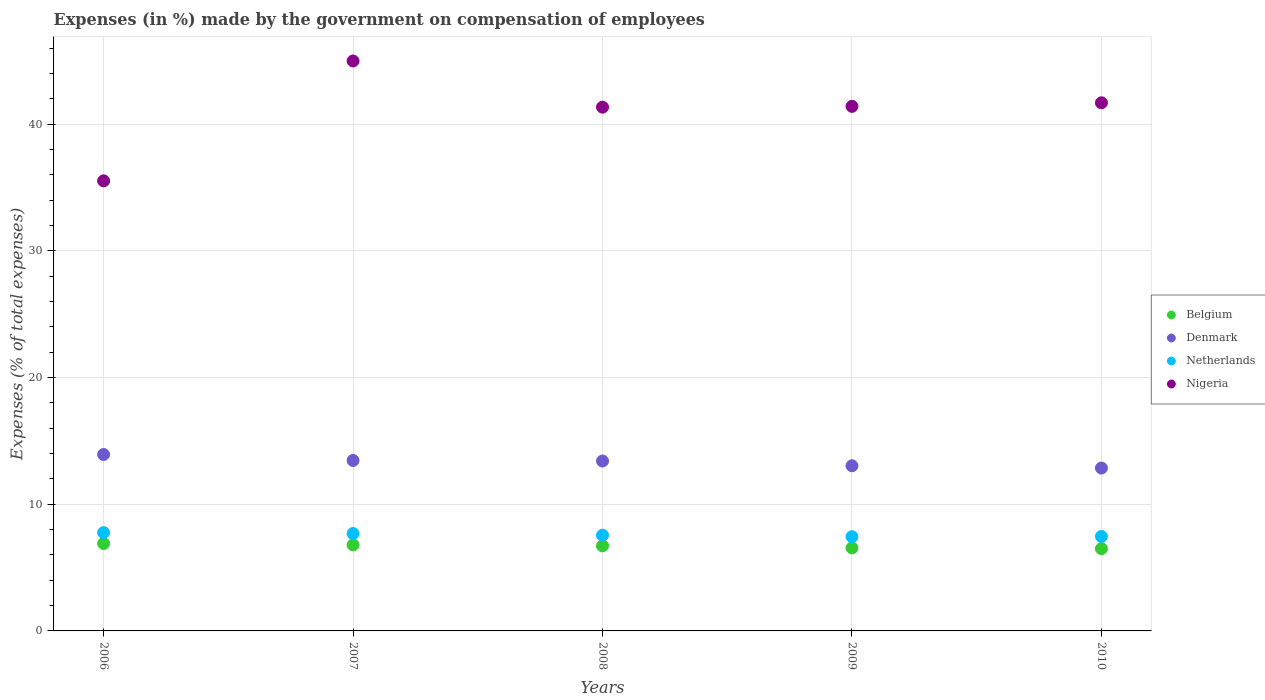What is the percentage of expenses made by the government on compensation of employees in Belgium in 2008?
Make the answer very short. 6.71. Across all years, what is the maximum percentage of expenses made by the government on compensation of employees in Netherlands?
Offer a terse response. 7.76. Across all years, what is the minimum percentage of expenses made by the government on compensation of employees in Nigeria?
Keep it short and to the point. 35.53. In which year was the percentage of expenses made by the government on compensation of employees in Netherlands minimum?
Your answer should be very brief. 2009. What is the total percentage of expenses made by the government on compensation of employees in Denmark in the graph?
Provide a short and direct response. 66.7. What is the difference between the percentage of expenses made by the government on compensation of employees in Denmark in 2007 and that in 2010?
Provide a succinct answer. 0.6. What is the difference between the percentage of expenses made by the government on compensation of employees in Denmark in 2010 and the percentage of expenses made by the government on compensation of employees in Nigeria in 2007?
Offer a very short reply. -32.14. What is the average percentage of expenses made by the government on compensation of employees in Netherlands per year?
Offer a terse response. 7.58. In the year 2010, what is the difference between the percentage of expenses made by the government on compensation of employees in Netherlands and percentage of expenses made by the government on compensation of employees in Belgium?
Provide a succinct answer. 0.97. What is the ratio of the percentage of expenses made by the government on compensation of employees in Belgium in 2006 to that in 2007?
Give a very brief answer. 1.02. Is the percentage of expenses made by the government on compensation of employees in Belgium in 2006 less than that in 2010?
Ensure brevity in your answer.  No. What is the difference between the highest and the second highest percentage of expenses made by the government on compensation of employees in Netherlands?
Ensure brevity in your answer.  0.07. What is the difference between the highest and the lowest percentage of expenses made by the government on compensation of employees in Nigeria?
Ensure brevity in your answer.  9.46. In how many years, is the percentage of expenses made by the government on compensation of employees in Denmark greater than the average percentage of expenses made by the government on compensation of employees in Denmark taken over all years?
Offer a very short reply. 3. Is the sum of the percentage of expenses made by the government on compensation of employees in Nigeria in 2006 and 2009 greater than the maximum percentage of expenses made by the government on compensation of employees in Denmark across all years?
Make the answer very short. Yes. Is it the case that in every year, the sum of the percentage of expenses made by the government on compensation of employees in Nigeria and percentage of expenses made by the government on compensation of employees in Denmark  is greater than the percentage of expenses made by the government on compensation of employees in Netherlands?
Your response must be concise. Yes. Is the percentage of expenses made by the government on compensation of employees in Belgium strictly greater than the percentage of expenses made by the government on compensation of employees in Netherlands over the years?
Offer a terse response. No. How many dotlines are there?
Your answer should be compact. 4. How many years are there in the graph?
Ensure brevity in your answer.  5. Does the graph contain any zero values?
Offer a very short reply. No. How many legend labels are there?
Your answer should be very brief. 4. How are the legend labels stacked?
Offer a terse response. Vertical. What is the title of the graph?
Give a very brief answer. Expenses (in %) made by the government on compensation of employees. What is the label or title of the X-axis?
Give a very brief answer. Years. What is the label or title of the Y-axis?
Give a very brief answer. Expenses (% of total expenses). What is the Expenses (% of total expenses) in Belgium in 2006?
Give a very brief answer. 6.9. What is the Expenses (% of total expenses) in Denmark in 2006?
Offer a terse response. 13.93. What is the Expenses (% of total expenses) in Netherlands in 2006?
Ensure brevity in your answer.  7.76. What is the Expenses (% of total expenses) of Nigeria in 2006?
Provide a succinct answer. 35.53. What is the Expenses (% of total expenses) in Belgium in 2007?
Your answer should be compact. 6.79. What is the Expenses (% of total expenses) of Denmark in 2007?
Give a very brief answer. 13.46. What is the Expenses (% of total expenses) of Netherlands in 2007?
Offer a very short reply. 7.69. What is the Expenses (% of total expenses) in Nigeria in 2007?
Ensure brevity in your answer.  45. What is the Expenses (% of total expenses) of Belgium in 2008?
Provide a short and direct response. 6.71. What is the Expenses (% of total expenses) in Denmark in 2008?
Your answer should be very brief. 13.41. What is the Expenses (% of total expenses) of Netherlands in 2008?
Your answer should be compact. 7.56. What is the Expenses (% of total expenses) in Nigeria in 2008?
Your answer should be very brief. 41.35. What is the Expenses (% of total expenses) in Belgium in 2009?
Give a very brief answer. 6.56. What is the Expenses (% of total expenses) of Denmark in 2009?
Your answer should be compact. 13.04. What is the Expenses (% of total expenses) of Netherlands in 2009?
Provide a succinct answer. 7.44. What is the Expenses (% of total expenses) of Nigeria in 2009?
Offer a very short reply. 41.42. What is the Expenses (% of total expenses) in Belgium in 2010?
Your answer should be very brief. 6.49. What is the Expenses (% of total expenses) of Denmark in 2010?
Provide a succinct answer. 12.86. What is the Expenses (% of total expenses) of Netherlands in 2010?
Provide a short and direct response. 7.46. What is the Expenses (% of total expenses) in Nigeria in 2010?
Offer a terse response. 41.7. Across all years, what is the maximum Expenses (% of total expenses) of Belgium?
Keep it short and to the point. 6.9. Across all years, what is the maximum Expenses (% of total expenses) in Denmark?
Offer a very short reply. 13.93. Across all years, what is the maximum Expenses (% of total expenses) of Netherlands?
Provide a succinct answer. 7.76. Across all years, what is the maximum Expenses (% of total expenses) in Nigeria?
Provide a short and direct response. 45. Across all years, what is the minimum Expenses (% of total expenses) in Belgium?
Give a very brief answer. 6.49. Across all years, what is the minimum Expenses (% of total expenses) in Denmark?
Provide a succinct answer. 12.86. Across all years, what is the minimum Expenses (% of total expenses) of Netherlands?
Your answer should be very brief. 7.44. Across all years, what is the minimum Expenses (% of total expenses) in Nigeria?
Keep it short and to the point. 35.53. What is the total Expenses (% of total expenses) of Belgium in the graph?
Offer a very short reply. 33.45. What is the total Expenses (% of total expenses) in Denmark in the graph?
Make the answer very short. 66.7. What is the total Expenses (% of total expenses) of Netherlands in the graph?
Give a very brief answer. 37.91. What is the total Expenses (% of total expenses) in Nigeria in the graph?
Ensure brevity in your answer.  205. What is the difference between the Expenses (% of total expenses) in Belgium in 2006 and that in 2007?
Your response must be concise. 0.1. What is the difference between the Expenses (% of total expenses) of Denmark in 2006 and that in 2007?
Give a very brief answer. 0.47. What is the difference between the Expenses (% of total expenses) of Netherlands in 2006 and that in 2007?
Offer a very short reply. 0.07. What is the difference between the Expenses (% of total expenses) in Nigeria in 2006 and that in 2007?
Your response must be concise. -9.46. What is the difference between the Expenses (% of total expenses) of Belgium in 2006 and that in 2008?
Your answer should be compact. 0.19. What is the difference between the Expenses (% of total expenses) of Denmark in 2006 and that in 2008?
Provide a succinct answer. 0.52. What is the difference between the Expenses (% of total expenses) in Netherlands in 2006 and that in 2008?
Offer a terse response. 0.2. What is the difference between the Expenses (% of total expenses) in Nigeria in 2006 and that in 2008?
Your response must be concise. -5.82. What is the difference between the Expenses (% of total expenses) of Belgium in 2006 and that in 2009?
Make the answer very short. 0.34. What is the difference between the Expenses (% of total expenses) of Denmark in 2006 and that in 2009?
Make the answer very short. 0.89. What is the difference between the Expenses (% of total expenses) in Netherlands in 2006 and that in 2009?
Your answer should be compact. 0.32. What is the difference between the Expenses (% of total expenses) of Nigeria in 2006 and that in 2009?
Your answer should be compact. -5.88. What is the difference between the Expenses (% of total expenses) in Belgium in 2006 and that in 2010?
Your response must be concise. 0.41. What is the difference between the Expenses (% of total expenses) of Denmark in 2006 and that in 2010?
Ensure brevity in your answer.  1.07. What is the difference between the Expenses (% of total expenses) of Netherlands in 2006 and that in 2010?
Keep it short and to the point. 0.3. What is the difference between the Expenses (% of total expenses) in Nigeria in 2006 and that in 2010?
Keep it short and to the point. -6.16. What is the difference between the Expenses (% of total expenses) of Belgium in 2007 and that in 2008?
Your answer should be very brief. 0.08. What is the difference between the Expenses (% of total expenses) in Denmark in 2007 and that in 2008?
Make the answer very short. 0.04. What is the difference between the Expenses (% of total expenses) in Netherlands in 2007 and that in 2008?
Provide a succinct answer. 0.13. What is the difference between the Expenses (% of total expenses) of Nigeria in 2007 and that in 2008?
Ensure brevity in your answer.  3.65. What is the difference between the Expenses (% of total expenses) in Belgium in 2007 and that in 2009?
Provide a short and direct response. 0.24. What is the difference between the Expenses (% of total expenses) of Denmark in 2007 and that in 2009?
Provide a short and direct response. 0.42. What is the difference between the Expenses (% of total expenses) of Netherlands in 2007 and that in 2009?
Your answer should be very brief. 0.25. What is the difference between the Expenses (% of total expenses) of Nigeria in 2007 and that in 2009?
Provide a short and direct response. 3.58. What is the difference between the Expenses (% of total expenses) of Belgium in 2007 and that in 2010?
Make the answer very short. 0.3. What is the difference between the Expenses (% of total expenses) in Denmark in 2007 and that in 2010?
Keep it short and to the point. 0.6. What is the difference between the Expenses (% of total expenses) of Netherlands in 2007 and that in 2010?
Your answer should be very brief. 0.23. What is the difference between the Expenses (% of total expenses) of Nigeria in 2007 and that in 2010?
Your response must be concise. 3.3. What is the difference between the Expenses (% of total expenses) of Belgium in 2008 and that in 2009?
Provide a short and direct response. 0.16. What is the difference between the Expenses (% of total expenses) in Denmark in 2008 and that in 2009?
Give a very brief answer. 0.38. What is the difference between the Expenses (% of total expenses) of Netherlands in 2008 and that in 2009?
Offer a terse response. 0.12. What is the difference between the Expenses (% of total expenses) of Nigeria in 2008 and that in 2009?
Your answer should be very brief. -0.06. What is the difference between the Expenses (% of total expenses) of Belgium in 2008 and that in 2010?
Make the answer very short. 0.22. What is the difference between the Expenses (% of total expenses) of Denmark in 2008 and that in 2010?
Give a very brief answer. 0.55. What is the difference between the Expenses (% of total expenses) in Netherlands in 2008 and that in 2010?
Provide a short and direct response. 0.1. What is the difference between the Expenses (% of total expenses) in Nigeria in 2008 and that in 2010?
Provide a succinct answer. -0.35. What is the difference between the Expenses (% of total expenses) of Belgium in 2009 and that in 2010?
Give a very brief answer. 0.06. What is the difference between the Expenses (% of total expenses) in Denmark in 2009 and that in 2010?
Give a very brief answer. 0.18. What is the difference between the Expenses (% of total expenses) in Netherlands in 2009 and that in 2010?
Make the answer very short. -0.02. What is the difference between the Expenses (% of total expenses) of Nigeria in 2009 and that in 2010?
Provide a short and direct response. -0.28. What is the difference between the Expenses (% of total expenses) of Belgium in 2006 and the Expenses (% of total expenses) of Denmark in 2007?
Provide a short and direct response. -6.56. What is the difference between the Expenses (% of total expenses) of Belgium in 2006 and the Expenses (% of total expenses) of Netherlands in 2007?
Offer a very short reply. -0.79. What is the difference between the Expenses (% of total expenses) of Belgium in 2006 and the Expenses (% of total expenses) of Nigeria in 2007?
Offer a very short reply. -38.1. What is the difference between the Expenses (% of total expenses) of Denmark in 2006 and the Expenses (% of total expenses) of Netherlands in 2007?
Make the answer very short. 6.24. What is the difference between the Expenses (% of total expenses) in Denmark in 2006 and the Expenses (% of total expenses) in Nigeria in 2007?
Provide a short and direct response. -31.07. What is the difference between the Expenses (% of total expenses) in Netherlands in 2006 and the Expenses (% of total expenses) in Nigeria in 2007?
Ensure brevity in your answer.  -37.24. What is the difference between the Expenses (% of total expenses) of Belgium in 2006 and the Expenses (% of total expenses) of Denmark in 2008?
Your answer should be compact. -6.52. What is the difference between the Expenses (% of total expenses) of Belgium in 2006 and the Expenses (% of total expenses) of Netherlands in 2008?
Your answer should be very brief. -0.66. What is the difference between the Expenses (% of total expenses) of Belgium in 2006 and the Expenses (% of total expenses) of Nigeria in 2008?
Your answer should be very brief. -34.45. What is the difference between the Expenses (% of total expenses) in Denmark in 2006 and the Expenses (% of total expenses) in Netherlands in 2008?
Offer a terse response. 6.37. What is the difference between the Expenses (% of total expenses) of Denmark in 2006 and the Expenses (% of total expenses) of Nigeria in 2008?
Provide a short and direct response. -27.42. What is the difference between the Expenses (% of total expenses) in Netherlands in 2006 and the Expenses (% of total expenses) in Nigeria in 2008?
Provide a succinct answer. -33.59. What is the difference between the Expenses (% of total expenses) of Belgium in 2006 and the Expenses (% of total expenses) of Denmark in 2009?
Keep it short and to the point. -6.14. What is the difference between the Expenses (% of total expenses) of Belgium in 2006 and the Expenses (% of total expenses) of Netherlands in 2009?
Offer a terse response. -0.54. What is the difference between the Expenses (% of total expenses) in Belgium in 2006 and the Expenses (% of total expenses) in Nigeria in 2009?
Provide a succinct answer. -34.52. What is the difference between the Expenses (% of total expenses) in Denmark in 2006 and the Expenses (% of total expenses) in Netherlands in 2009?
Your answer should be very brief. 6.49. What is the difference between the Expenses (% of total expenses) of Denmark in 2006 and the Expenses (% of total expenses) of Nigeria in 2009?
Keep it short and to the point. -27.49. What is the difference between the Expenses (% of total expenses) of Netherlands in 2006 and the Expenses (% of total expenses) of Nigeria in 2009?
Ensure brevity in your answer.  -33.65. What is the difference between the Expenses (% of total expenses) in Belgium in 2006 and the Expenses (% of total expenses) in Denmark in 2010?
Your answer should be very brief. -5.96. What is the difference between the Expenses (% of total expenses) in Belgium in 2006 and the Expenses (% of total expenses) in Netherlands in 2010?
Offer a very short reply. -0.56. What is the difference between the Expenses (% of total expenses) in Belgium in 2006 and the Expenses (% of total expenses) in Nigeria in 2010?
Make the answer very short. -34.8. What is the difference between the Expenses (% of total expenses) of Denmark in 2006 and the Expenses (% of total expenses) of Netherlands in 2010?
Your answer should be very brief. 6.47. What is the difference between the Expenses (% of total expenses) of Denmark in 2006 and the Expenses (% of total expenses) of Nigeria in 2010?
Give a very brief answer. -27.77. What is the difference between the Expenses (% of total expenses) of Netherlands in 2006 and the Expenses (% of total expenses) of Nigeria in 2010?
Provide a short and direct response. -33.94. What is the difference between the Expenses (% of total expenses) in Belgium in 2007 and the Expenses (% of total expenses) in Denmark in 2008?
Keep it short and to the point. -6.62. What is the difference between the Expenses (% of total expenses) in Belgium in 2007 and the Expenses (% of total expenses) in Netherlands in 2008?
Provide a short and direct response. -0.76. What is the difference between the Expenses (% of total expenses) of Belgium in 2007 and the Expenses (% of total expenses) of Nigeria in 2008?
Offer a very short reply. -34.56. What is the difference between the Expenses (% of total expenses) in Denmark in 2007 and the Expenses (% of total expenses) in Netherlands in 2008?
Keep it short and to the point. 5.9. What is the difference between the Expenses (% of total expenses) of Denmark in 2007 and the Expenses (% of total expenses) of Nigeria in 2008?
Offer a terse response. -27.89. What is the difference between the Expenses (% of total expenses) in Netherlands in 2007 and the Expenses (% of total expenses) in Nigeria in 2008?
Offer a very short reply. -33.66. What is the difference between the Expenses (% of total expenses) of Belgium in 2007 and the Expenses (% of total expenses) of Denmark in 2009?
Keep it short and to the point. -6.24. What is the difference between the Expenses (% of total expenses) in Belgium in 2007 and the Expenses (% of total expenses) in Netherlands in 2009?
Your response must be concise. -0.64. What is the difference between the Expenses (% of total expenses) of Belgium in 2007 and the Expenses (% of total expenses) of Nigeria in 2009?
Your answer should be compact. -34.62. What is the difference between the Expenses (% of total expenses) in Denmark in 2007 and the Expenses (% of total expenses) in Netherlands in 2009?
Make the answer very short. 6.02. What is the difference between the Expenses (% of total expenses) of Denmark in 2007 and the Expenses (% of total expenses) of Nigeria in 2009?
Make the answer very short. -27.96. What is the difference between the Expenses (% of total expenses) of Netherlands in 2007 and the Expenses (% of total expenses) of Nigeria in 2009?
Provide a short and direct response. -33.73. What is the difference between the Expenses (% of total expenses) of Belgium in 2007 and the Expenses (% of total expenses) of Denmark in 2010?
Give a very brief answer. -6.07. What is the difference between the Expenses (% of total expenses) of Belgium in 2007 and the Expenses (% of total expenses) of Netherlands in 2010?
Your answer should be very brief. -0.67. What is the difference between the Expenses (% of total expenses) of Belgium in 2007 and the Expenses (% of total expenses) of Nigeria in 2010?
Offer a terse response. -34.9. What is the difference between the Expenses (% of total expenses) in Denmark in 2007 and the Expenses (% of total expenses) in Netherlands in 2010?
Give a very brief answer. 6. What is the difference between the Expenses (% of total expenses) in Denmark in 2007 and the Expenses (% of total expenses) in Nigeria in 2010?
Make the answer very short. -28.24. What is the difference between the Expenses (% of total expenses) in Netherlands in 2007 and the Expenses (% of total expenses) in Nigeria in 2010?
Ensure brevity in your answer.  -34.01. What is the difference between the Expenses (% of total expenses) of Belgium in 2008 and the Expenses (% of total expenses) of Denmark in 2009?
Keep it short and to the point. -6.33. What is the difference between the Expenses (% of total expenses) of Belgium in 2008 and the Expenses (% of total expenses) of Netherlands in 2009?
Offer a very short reply. -0.72. What is the difference between the Expenses (% of total expenses) of Belgium in 2008 and the Expenses (% of total expenses) of Nigeria in 2009?
Offer a very short reply. -34.7. What is the difference between the Expenses (% of total expenses) of Denmark in 2008 and the Expenses (% of total expenses) of Netherlands in 2009?
Make the answer very short. 5.98. What is the difference between the Expenses (% of total expenses) in Denmark in 2008 and the Expenses (% of total expenses) in Nigeria in 2009?
Provide a short and direct response. -28. What is the difference between the Expenses (% of total expenses) in Netherlands in 2008 and the Expenses (% of total expenses) in Nigeria in 2009?
Give a very brief answer. -33.86. What is the difference between the Expenses (% of total expenses) in Belgium in 2008 and the Expenses (% of total expenses) in Denmark in 2010?
Keep it short and to the point. -6.15. What is the difference between the Expenses (% of total expenses) in Belgium in 2008 and the Expenses (% of total expenses) in Netherlands in 2010?
Make the answer very short. -0.75. What is the difference between the Expenses (% of total expenses) of Belgium in 2008 and the Expenses (% of total expenses) of Nigeria in 2010?
Your answer should be compact. -34.98. What is the difference between the Expenses (% of total expenses) in Denmark in 2008 and the Expenses (% of total expenses) in Netherlands in 2010?
Provide a succinct answer. 5.95. What is the difference between the Expenses (% of total expenses) of Denmark in 2008 and the Expenses (% of total expenses) of Nigeria in 2010?
Provide a short and direct response. -28.28. What is the difference between the Expenses (% of total expenses) in Netherlands in 2008 and the Expenses (% of total expenses) in Nigeria in 2010?
Keep it short and to the point. -34.14. What is the difference between the Expenses (% of total expenses) of Belgium in 2009 and the Expenses (% of total expenses) of Denmark in 2010?
Provide a succinct answer. -6.3. What is the difference between the Expenses (% of total expenses) in Belgium in 2009 and the Expenses (% of total expenses) in Netherlands in 2010?
Ensure brevity in your answer.  -0.91. What is the difference between the Expenses (% of total expenses) of Belgium in 2009 and the Expenses (% of total expenses) of Nigeria in 2010?
Make the answer very short. -35.14. What is the difference between the Expenses (% of total expenses) of Denmark in 2009 and the Expenses (% of total expenses) of Netherlands in 2010?
Give a very brief answer. 5.58. What is the difference between the Expenses (% of total expenses) in Denmark in 2009 and the Expenses (% of total expenses) in Nigeria in 2010?
Give a very brief answer. -28.66. What is the difference between the Expenses (% of total expenses) in Netherlands in 2009 and the Expenses (% of total expenses) in Nigeria in 2010?
Offer a terse response. -34.26. What is the average Expenses (% of total expenses) in Belgium per year?
Provide a short and direct response. 6.69. What is the average Expenses (% of total expenses) of Denmark per year?
Your response must be concise. 13.34. What is the average Expenses (% of total expenses) in Netherlands per year?
Ensure brevity in your answer.  7.58. What is the average Expenses (% of total expenses) in Nigeria per year?
Your answer should be compact. 41. In the year 2006, what is the difference between the Expenses (% of total expenses) in Belgium and Expenses (% of total expenses) in Denmark?
Provide a short and direct response. -7.03. In the year 2006, what is the difference between the Expenses (% of total expenses) of Belgium and Expenses (% of total expenses) of Netherlands?
Your response must be concise. -0.86. In the year 2006, what is the difference between the Expenses (% of total expenses) of Belgium and Expenses (% of total expenses) of Nigeria?
Offer a terse response. -28.64. In the year 2006, what is the difference between the Expenses (% of total expenses) in Denmark and Expenses (% of total expenses) in Netherlands?
Make the answer very short. 6.17. In the year 2006, what is the difference between the Expenses (% of total expenses) of Denmark and Expenses (% of total expenses) of Nigeria?
Offer a very short reply. -21.61. In the year 2006, what is the difference between the Expenses (% of total expenses) of Netherlands and Expenses (% of total expenses) of Nigeria?
Provide a succinct answer. -27.77. In the year 2007, what is the difference between the Expenses (% of total expenses) in Belgium and Expenses (% of total expenses) in Denmark?
Offer a terse response. -6.66. In the year 2007, what is the difference between the Expenses (% of total expenses) of Belgium and Expenses (% of total expenses) of Netherlands?
Keep it short and to the point. -0.9. In the year 2007, what is the difference between the Expenses (% of total expenses) in Belgium and Expenses (% of total expenses) in Nigeria?
Give a very brief answer. -38.21. In the year 2007, what is the difference between the Expenses (% of total expenses) in Denmark and Expenses (% of total expenses) in Netherlands?
Offer a terse response. 5.77. In the year 2007, what is the difference between the Expenses (% of total expenses) of Denmark and Expenses (% of total expenses) of Nigeria?
Your response must be concise. -31.54. In the year 2007, what is the difference between the Expenses (% of total expenses) of Netherlands and Expenses (% of total expenses) of Nigeria?
Your answer should be compact. -37.31. In the year 2008, what is the difference between the Expenses (% of total expenses) of Belgium and Expenses (% of total expenses) of Denmark?
Provide a succinct answer. -6.7. In the year 2008, what is the difference between the Expenses (% of total expenses) in Belgium and Expenses (% of total expenses) in Netherlands?
Make the answer very short. -0.84. In the year 2008, what is the difference between the Expenses (% of total expenses) of Belgium and Expenses (% of total expenses) of Nigeria?
Give a very brief answer. -34.64. In the year 2008, what is the difference between the Expenses (% of total expenses) in Denmark and Expenses (% of total expenses) in Netherlands?
Keep it short and to the point. 5.86. In the year 2008, what is the difference between the Expenses (% of total expenses) in Denmark and Expenses (% of total expenses) in Nigeria?
Your response must be concise. -27.94. In the year 2008, what is the difference between the Expenses (% of total expenses) of Netherlands and Expenses (% of total expenses) of Nigeria?
Keep it short and to the point. -33.79. In the year 2009, what is the difference between the Expenses (% of total expenses) of Belgium and Expenses (% of total expenses) of Denmark?
Give a very brief answer. -6.48. In the year 2009, what is the difference between the Expenses (% of total expenses) in Belgium and Expenses (% of total expenses) in Netherlands?
Offer a terse response. -0.88. In the year 2009, what is the difference between the Expenses (% of total expenses) of Belgium and Expenses (% of total expenses) of Nigeria?
Make the answer very short. -34.86. In the year 2009, what is the difference between the Expenses (% of total expenses) in Denmark and Expenses (% of total expenses) in Netherlands?
Make the answer very short. 5.6. In the year 2009, what is the difference between the Expenses (% of total expenses) in Denmark and Expenses (% of total expenses) in Nigeria?
Your answer should be compact. -28.38. In the year 2009, what is the difference between the Expenses (% of total expenses) in Netherlands and Expenses (% of total expenses) in Nigeria?
Give a very brief answer. -33.98. In the year 2010, what is the difference between the Expenses (% of total expenses) of Belgium and Expenses (% of total expenses) of Denmark?
Provide a succinct answer. -6.37. In the year 2010, what is the difference between the Expenses (% of total expenses) in Belgium and Expenses (% of total expenses) in Netherlands?
Your response must be concise. -0.97. In the year 2010, what is the difference between the Expenses (% of total expenses) in Belgium and Expenses (% of total expenses) in Nigeria?
Give a very brief answer. -35.2. In the year 2010, what is the difference between the Expenses (% of total expenses) in Denmark and Expenses (% of total expenses) in Netherlands?
Ensure brevity in your answer.  5.4. In the year 2010, what is the difference between the Expenses (% of total expenses) of Denmark and Expenses (% of total expenses) of Nigeria?
Offer a very short reply. -28.84. In the year 2010, what is the difference between the Expenses (% of total expenses) in Netherlands and Expenses (% of total expenses) in Nigeria?
Offer a very short reply. -34.23. What is the ratio of the Expenses (% of total expenses) in Belgium in 2006 to that in 2007?
Offer a terse response. 1.02. What is the ratio of the Expenses (% of total expenses) of Denmark in 2006 to that in 2007?
Offer a very short reply. 1.03. What is the ratio of the Expenses (% of total expenses) of Netherlands in 2006 to that in 2007?
Provide a succinct answer. 1.01. What is the ratio of the Expenses (% of total expenses) in Nigeria in 2006 to that in 2007?
Offer a very short reply. 0.79. What is the ratio of the Expenses (% of total expenses) in Belgium in 2006 to that in 2008?
Your answer should be compact. 1.03. What is the ratio of the Expenses (% of total expenses) in Denmark in 2006 to that in 2008?
Your answer should be very brief. 1.04. What is the ratio of the Expenses (% of total expenses) in Nigeria in 2006 to that in 2008?
Offer a very short reply. 0.86. What is the ratio of the Expenses (% of total expenses) of Belgium in 2006 to that in 2009?
Offer a terse response. 1.05. What is the ratio of the Expenses (% of total expenses) in Denmark in 2006 to that in 2009?
Give a very brief answer. 1.07. What is the ratio of the Expenses (% of total expenses) in Netherlands in 2006 to that in 2009?
Keep it short and to the point. 1.04. What is the ratio of the Expenses (% of total expenses) in Nigeria in 2006 to that in 2009?
Your response must be concise. 0.86. What is the ratio of the Expenses (% of total expenses) of Denmark in 2006 to that in 2010?
Make the answer very short. 1.08. What is the ratio of the Expenses (% of total expenses) of Netherlands in 2006 to that in 2010?
Your response must be concise. 1.04. What is the ratio of the Expenses (% of total expenses) of Nigeria in 2006 to that in 2010?
Offer a very short reply. 0.85. What is the ratio of the Expenses (% of total expenses) of Belgium in 2007 to that in 2008?
Ensure brevity in your answer.  1.01. What is the ratio of the Expenses (% of total expenses) in Denmark in 2007 to that in 2008?
Offer a terse response. 1. What is the ratio of the Expenses (% of total expenses) of Netherlands in 2007 to that in 2008?
Ensure brevity in your answer.  1.02. What is the ratio of the Expenses (% of total expenses) of Nigeria in 2007 to that in 2008?
Offer a terse response. 1.09. What is the ratio of the Expenses (% of total expenses) of Belgium in 2007 to that in 2009?
Provide a succinct answer. 1.04. What is the ratio of the Expenses (% of total expenses) in Denmark in 2007 to that in 2009?
Give a very brief answer. 1.03. What is the ratio of the Expenses (% of total expenses) in Netherlands in 2007 to that in 2009?
Ensure brevity in your answer.  1.03. What is the ratio of the Expenses (% of total expenses) of Nigeria in 2007 to that in 2009?
Your answer should be compact. 1.09. What is the ratio of the Expenses (% of total expenses) in Belgium in 2007 to that in 2010?
Your answer should be very brief. 1.05. What is the ratio of the Expenses (% of total expenses) of Denmark in 2007 to that in 2010?
Your response must be concise. 1.05. What is the ratio of the Expenses (% of total expenses) in Netherlands in 2007 to that in 2010?
Your answer should be compact. 1.03. What is the ratio of the Expenses (% of total expenses) of Nigeria in 2007 to that in 2010?
Provide a short and direct response. 1.08. What is the ratio of the Expenses (% of total expenses) of Belgium in 2008 to that in 2009?
Offer a very short reply. 1.02. What is the ratio of the Expenses (% of total expenses) of Denmark in 2008 to that in 2009?
Your answer should be compact. 1.03. What is the ratio of the Expenses (% of total expenses) in Netherlands in 2008 to that in 2009?
Give a very brief answer. 1.02. What is the ratio of the Expenses (% of total expenses) of Belgium in 2008 to that in 2010?
Offer a very short reply. 1.03. What is the ratio of the Expenses (% of total expenses) in Denmark in 2008 to that in 2010?
Your response must be concise. 1.04. What is the ratio of the Expenses (% of total expenses) of Netherlands in 2008 to that in 2010?
Give a very brief answer. 1.01. What is the ratio of the Expenses (% of total expenses) of Nigeria in 2008 to that in 2010?
Make the answer very short. 0.99. What is the ratio of the Expenses (% of total expenses) in Belgium in 2009 to that in 2010?
Offer a terse response. 1.01. What is the ratio of the Expenses (% of total expenses) of Denmark in 2009 to that in 2010?
Give a very brief answer. 1.01. What is the ratio of the Expenses (% of total expenses) in Netherlands in 2009 to that in 2010?
Make the answer very short. 1. What is the difference between the highest and the second highest Expenses (% of total expenses) in Belgium?
Your response must be concise. 0.1. What is the difference between the highest and the second highest Expenses (% of total expenses) of Denmark?
Provide a short and direct response. 0.47. What is the difference between the highest and the second highest Expenses (% of total expenses) in Netherlands?
Provide a short and direct response. 0.07. What is the difference between the highest and the second highest Expenses (% of total expenses) of Nigeria?
Your answer should be very brief. 3.3. What is the difference between the highest and the lowest Expenses (% of total expenses) of Belgium?
Make the answer very short. 0.41. What is the difference between the highest and the lowest Expenses (% of total expenses) in Denmark?
Provide a short and direct response. 1.07. What is the difference between the highest and the lowest Expenses (% of total expenses) in Netherlands?
Your response must be concise. 0.32. What is the difference between the highest and the lowest Expenses (% of total expenses) in Nigeria?
Your answer should be very brief. 9.46. 